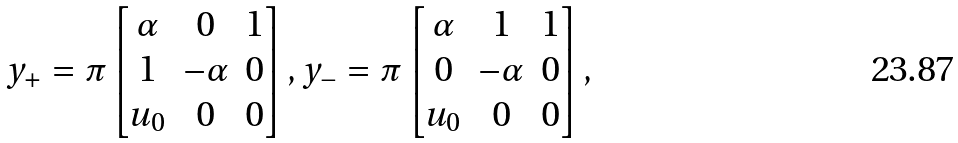<formula> <loc_0><loc_0><loc_500><loc_500>y _ { + } = \pi \begin{bmatrix} \alpha & 0 & 1 \\ 1 & - \alpha & 0 \\ u _ { 0 } & 0 & 0 \end{bmatrix} , y _ { - } = \pi \begin{bmatrix} \alpha & 1 & 1 \\ 0 & - \alpha & 0 \\ u _ { 0 } & 0 & 0 \end{bmatrix} ,</formula> 